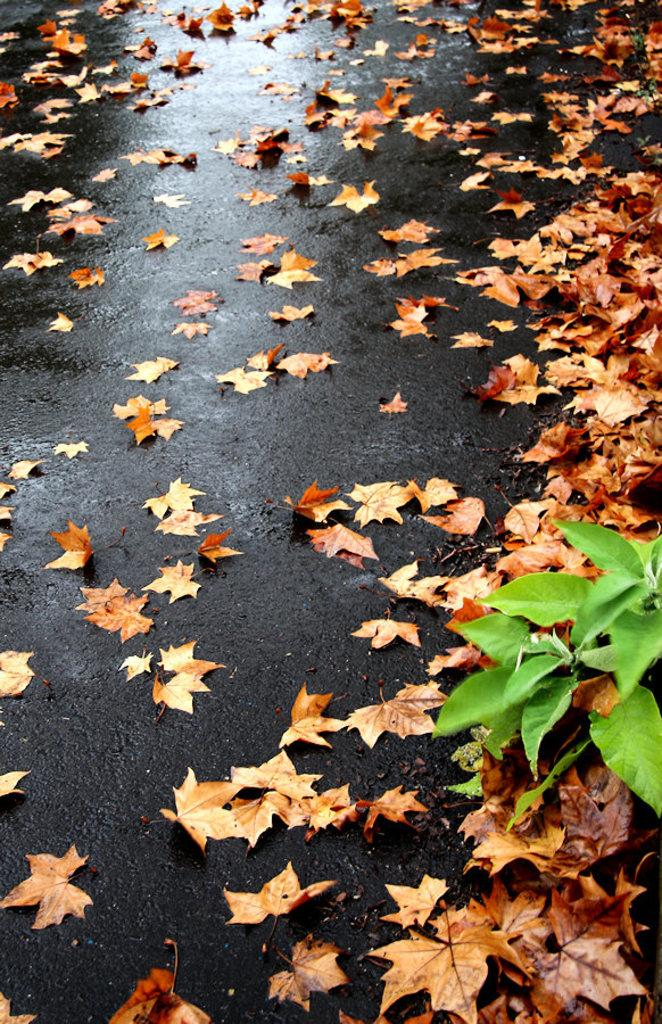What is the condition of the road in the image? The road in the image is wet. What can be seen on the wet road? There are maple leaves on the road. What type of vegetation is on the right side of the image? There are green leaves with stems on the right side of the image. What scent is emitted from the steam in the image? There is no steam present in the image, so there is no scent to describe. 